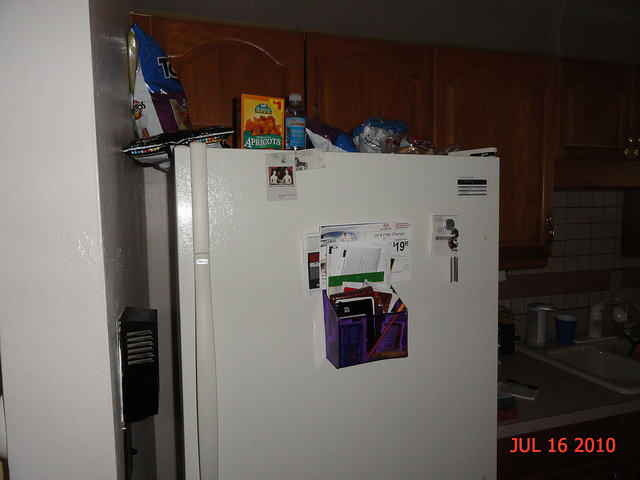<image>What is written on the front of the fridge? It is ambiguous what is written on the front of the fridge. It could be '19.99' or 'papers'. What is written on the front of the fridge? I am not sure what is written on the front of the fridge. It could be '19.99', 'papers', 'little box', '$19.88' or 'magnets'. 